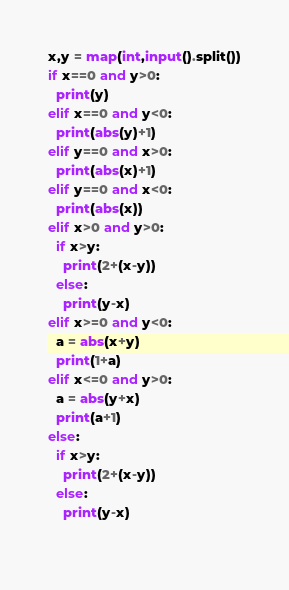Convert code to text. <code><loc_0><loc_0><loc_500><loc_500><_Python_>x,y = map(int,input().split())
if x==0 and y>0:
  print(y)
elif x==0 and y<0:
  print(abs(y)+1)
elif y==0 and x>0:
  print(abs(x)+1)
elif y==0 and x<0:
  print(abs(x))
elif x>0 and y>0:
  if x>y:
    print(2+(x-y))
  else:
    print(y-x)
elif x>=0 and y<0:
  a = abs(x+y)
  print(1+a)
elif x<=0 and y>0:
  a = abs(y+x)
  print(a+1)
else:
  if x>y:
    print(2+(x-y))
  else:
    print(y-x)
  </code> 